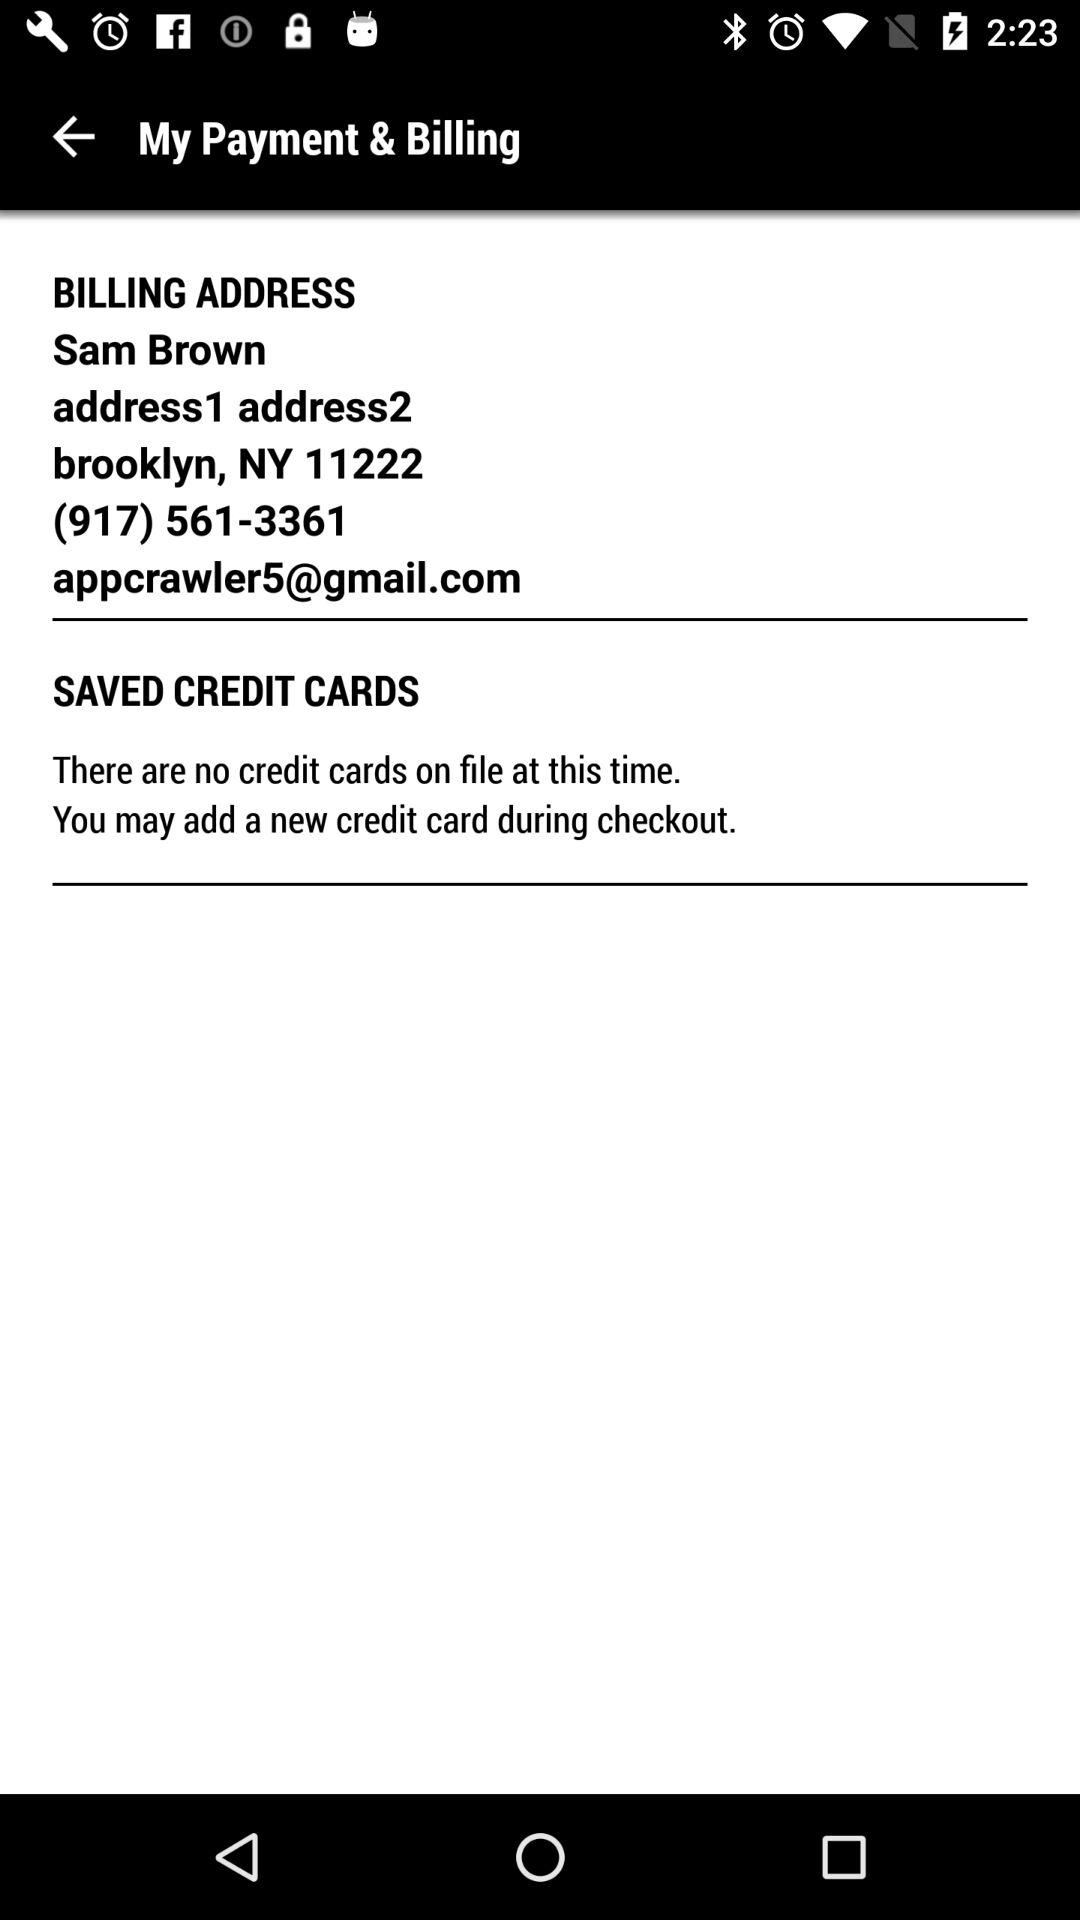How many credit cards are saved in the user's account?
Answer the question using a single word or phrase. 0 